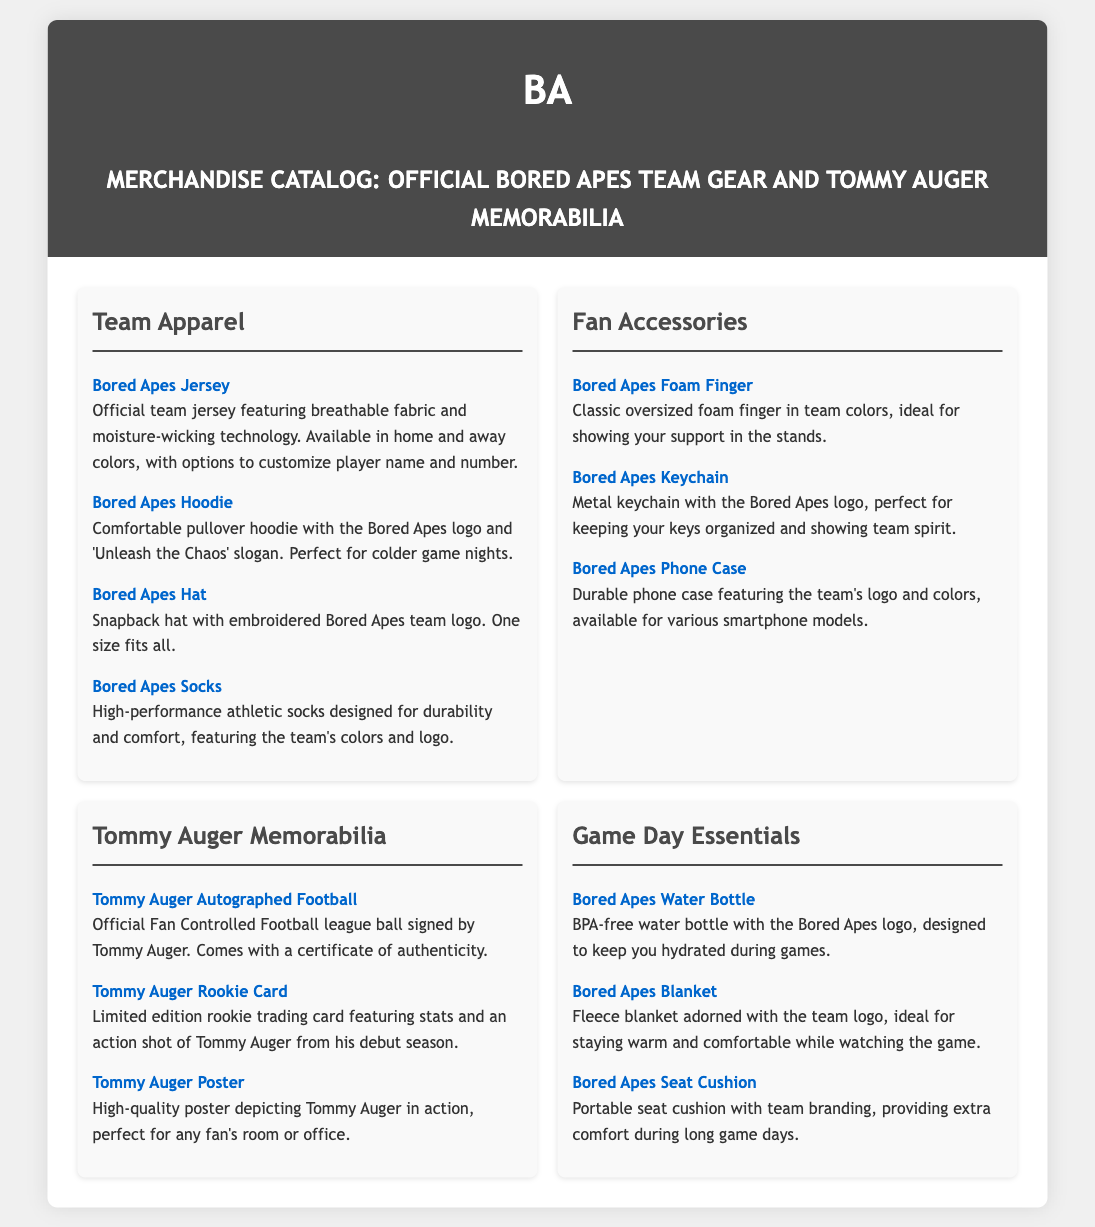what type of material is the Bored Apes Jersey made from? The Bored Apes Jersey features breathable fabric and moisture-wicking technology.
Answer: breathable fabric what slogan is on the Bored Apes Hoodie? The Bored Apes Hoodie has the slogan 'Unleash the Chaos'.
Answer: Unleash the Chaos how many items are in the Fan Accessories section? The document lists three items under the Fan Accessories section.
Answer: three what is included with the Tommy Auger Autographed Football? The football comes with a certificate of authenticity.
Answer: certificate of authenticity what kind of trading card features Tommy Auger? The document mentions a limited edition rookie trading card.
Answer: rookie trading card what does the Bored Apes Blanket depict? The Bored Apes Blanket is adorned with the team logo.
Answer: team logo which item is designed for hydration during games? The item designed to keep you hydrated is the Bored Apes Water Bottle.
Answer: Bored Apes Water Bottle what type of item is the Bored Apes Foam Finger? The Bored Apes Foam Finger is a classic oversized foam finger.
Answer: oversized foam finger what is the primary function of the Bored Apes Seat Cushion? The primary function of the cushion is to provide extra comfort during long game days.
Answer: extra comfort 